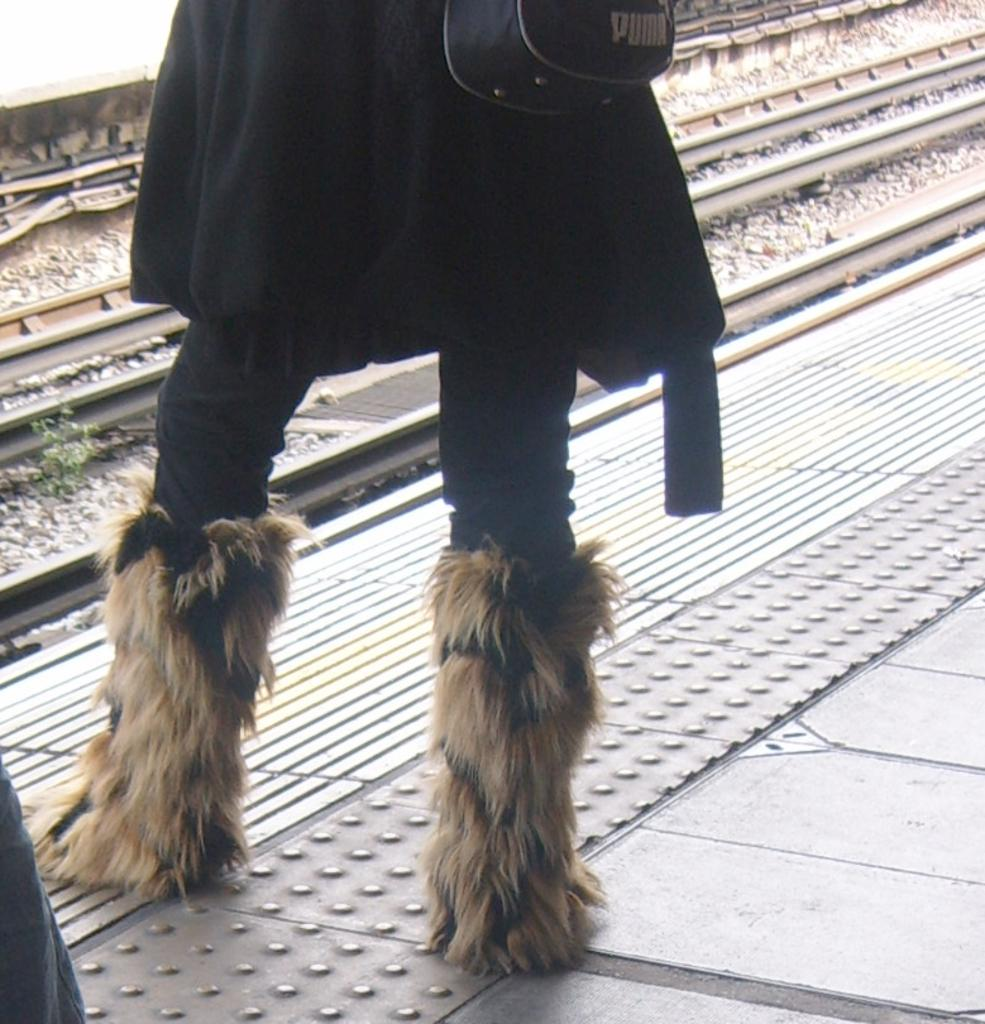What is the main subject of the image? There is a person in the image. Where is the person located in the image? The person is standing on a path. What can be seen in front of the person? There are railway tracks in front of the person. What type of wax is being used to create the person's clothing in the image? There is no wax present in the image, and the person's clothing is not made of wax. 